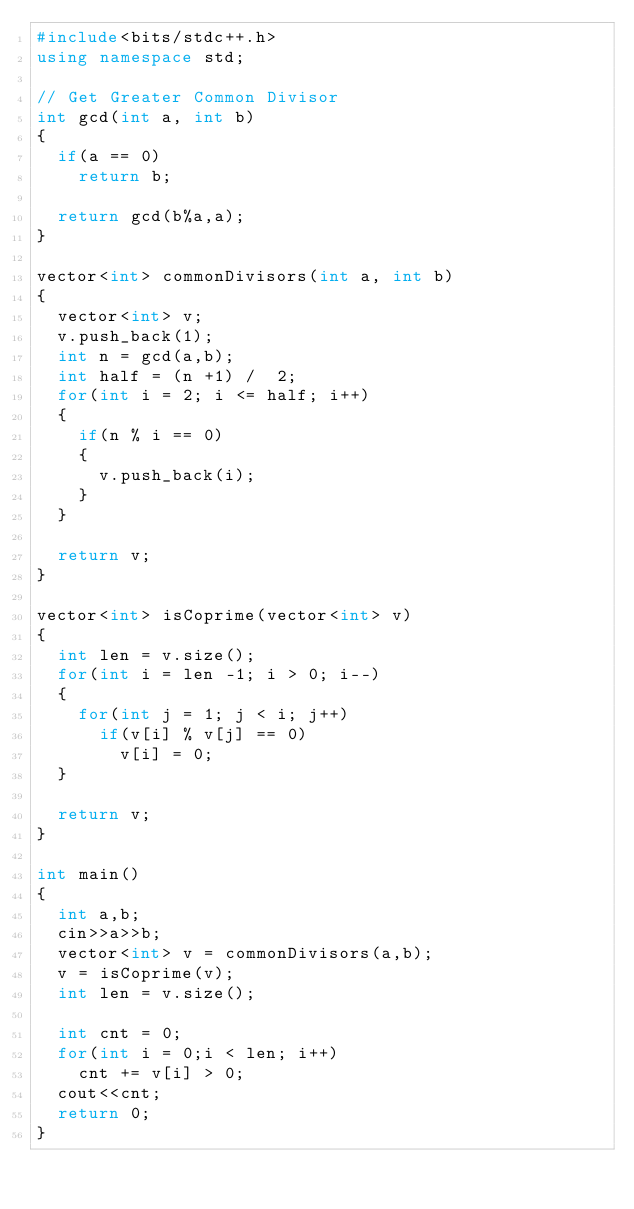Convert code to text. <code><loc_0><loc_0><loc_500><loc_500><_C++_>#include<bits/stdc++.h>
using namespace std;

// Get Greater Common Divisor
int gcd(int a, int b)
{
	if(a == 0)
		return b;

	return gcd(b%a,a);
}

vector<int> commonDivisors(int a, int b)
{
	vector<int> v;
	v.push_back(1);
	int n = gcd(a,b);
	int half = (n +1) /  2;
	for(int i = 2; i <= half; i++)
	{
		if(n % i == 0)
		{
			v.push_back(i);
		}
	}

	return v;
}

vector<int> isCoprime(vector<int> v)
{
	int len = v.size();
	for(int i = len -1; i > 0; i--)
	{
		for(int j = 1; j < i; j++)
			if(v[i] % v[j] == 0)
				v[i] = 0;
	}

	return v;
}

int main()
{
	int a,b;
	cin>>a>>b;
	vector<int> v = commonDivisors(a,b);
	v = isCoprime(v);
	int len = v.size();

	int cnt = 0;
	for(int i = 0;i < len; i++)
		cnt += v[i] > 0;
	cout<<cnt;
	return 0;
}
</code> 